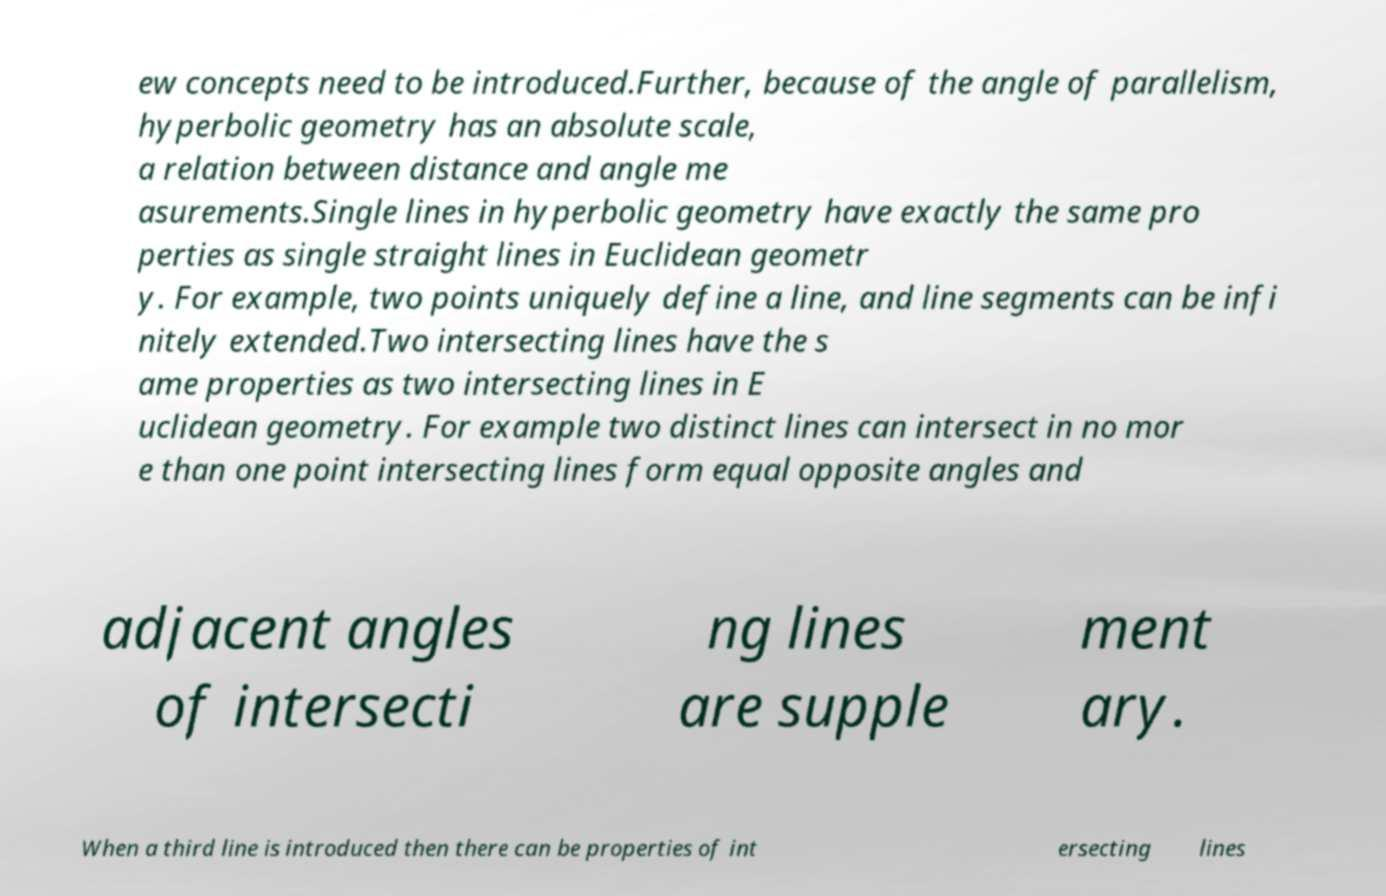Can you accurately transcribe the text from the provided image for me? ew concepts need to be introduced.Further, because of the angle of parallelism, hyperbolic geometry has an absolute scale, a relation between distance and angle me asurements.Single lines in hyperbolic geometry have exactly the same pro perties as single straight lines in Euclidean geometr y. For example, two points uniquely define a line, and line segments can be infi nitely extended.Two intersecting lines have the s ame properties as two intersecting lines in E uclidean geometry. For example two distinct lines can intersect in no mor e than one point intersecting lines form equal opposite angles and adjacent angles of intersecti ng lines are supple ment ary. When a third line is introduced then there can be properties of int ersecting lines 